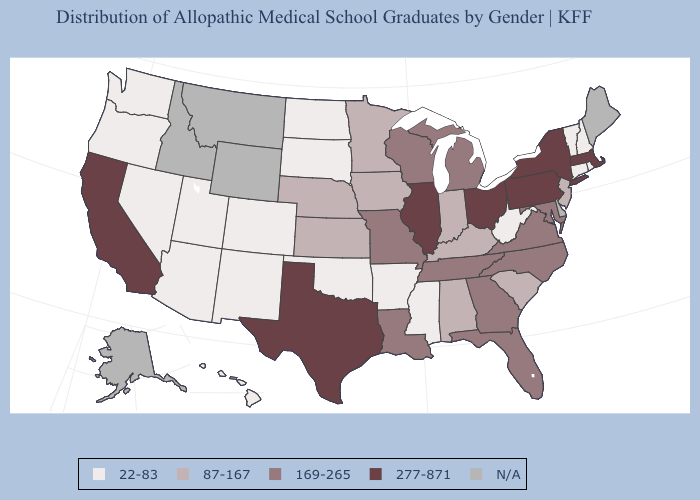Name the states that have a value in the range 169-265?
Concise answer only. Florida, Georgia, Louisiana, Maryland, Michigan, Missouri, North Carolina, Tennessee, Virginia, Wisconsin. Among the states that border Virginia , which have the lowest value?
Answer briefly. West Virginia. Name the states that have a value in the range 169-265?
Keep it brief. Florida, Georgia, Louisiana, Maryland, Michigan, Missouri, North Carolina, Tennessee, Virginia, Wisconsin. Which states have the lowest value in the South?
Keep it brief. Arkansas, Mississippi, Oklahoma, West Virginia. What is the value of Massachusetts?
Be succinct. 277-871. Is the legend a continuous bar?
Answer briefly. No. Name the states that have a value in the range 87-167?
Be succinct. Alabama, Indiana, Iowa, Kansas, Kentucky, Minnesota, Nebraska, New Jersey, South Carolina. Which states hav the highest value in the South?
Answer briefly. Texas. Name the states that have a value in the range 277-871?
Give a very brief answer. California, Illinois, Massachusetts, New York, Ohio, Pennsylvania, Texas. What is the highest value in states that border Illinois?
Concise answer only. 169-265. Does Oregon have the highest value in the West?
Answer briefly. No. What is the value of Washington?
Concise answer only. 22-83. Name the states that have a value in the range 277-871?
Answer briefly. California, Illinois, Massachusetts, New York, Ohio, Pennsylvania, Texas. Name the states that have a value in the range 169-265?
Quick response, please. Florida, Georgia, Louisiana, Maryland, Michigan, Missouri, North Carolina, Tennessee, Virginia, Wisconsin. 